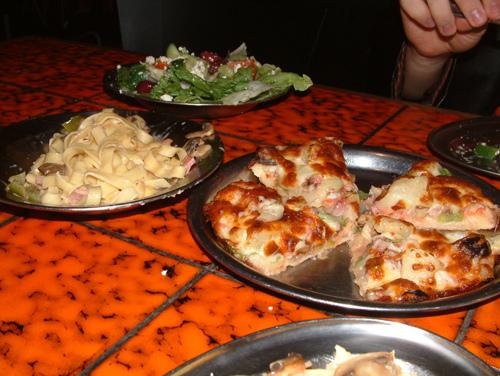Will this person eat everything on the table?
Be succinct. No. What colors are on the edge of the closest plate?
Short answer required. Silver. Is there pasta on the table?
Be succinct. Yes. What is this person having with their pizza that is more healthy?
Answer briefly. Salad. 